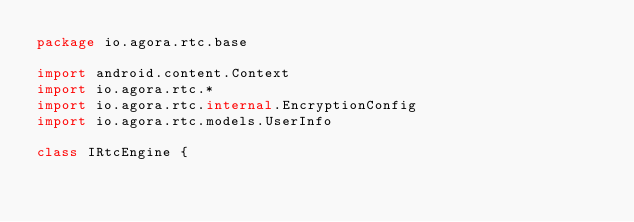<code> <loc_0><loc_0><loc_500><loc_500><_Kotlin_>package io.agora.rtc.base

import android.content.Context
import io.agora.rtc.*
import io.agora.rtc.internal.EncryptionConfig
import io.agora.rtc.models.UserInfo

class IRtcEngine {</code> 